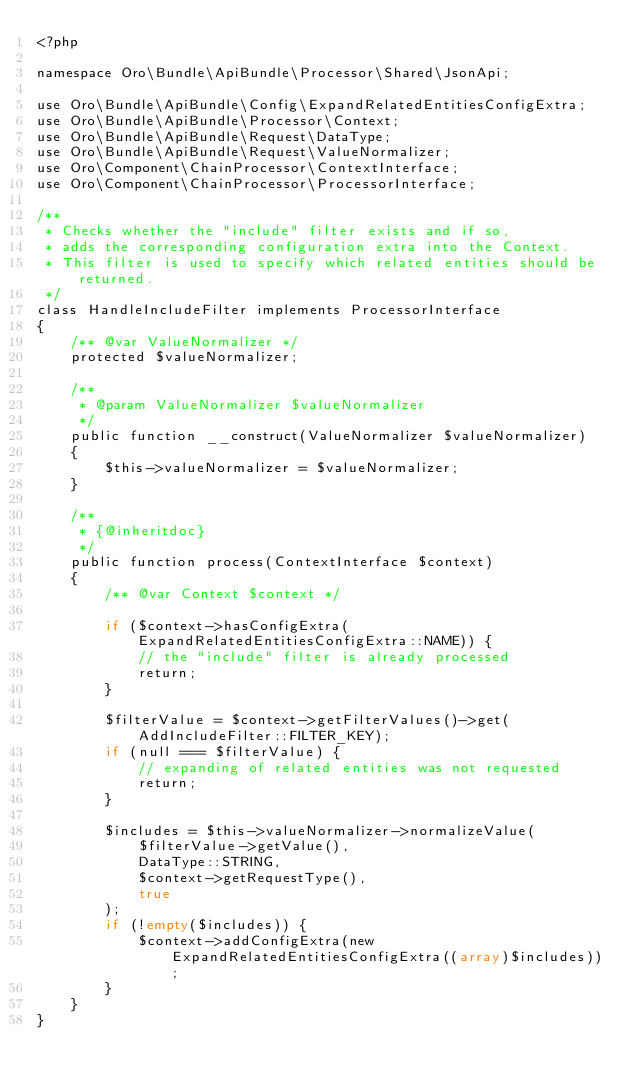Convert code to text. <code><loc_0><loc_0><loc_500><loc_500><_PHP_><?php

namespace Oro\Bundle\ApiBundle\Processor\Shared\JsonApi;

use Oro\Bundle\ApiBundle\Config\ExpandRelatedEntitiesConfigExtra;
use Oro\Bundle\ApiBundle\Processor\Context;
use Oro\Bundle\ApiBundle\Request\DataType;
use Oro\Bundle\ApiBundle\Request\ValueNormalizer;
use Oro\Component\ChainProcessor\ContextInterface;
use Oro\Component\ChainProcessor\ProcessorInterface;

/**
 * Checks whether the "include" filter exists and if so,
 * adds the corresponding configuration extra into the Context.
 * This filter is used to specify which related entities should be returned.
 */
class HandleIncludeFilter implements ProcessorInterface
{
    /** @var ValueNormalizer */
    protected $valueNormalizer;

    /**
     * @param ValueNormalizer $valueNormalizer
     */
    public function __construct(ValueNormalizer $valueNormalizer)
    {
        $this->valueNormalizer = $valueNormalizer;
    }

    /**
     * {@inheritdoc}
     */
    public function process(ContextInterface $context)
    {
        /** @var Context $context */

        if ($context->hasConfigExtra(ExpandRelatedEntitiesConfigExtra::NAME)) {
            // the "include" filter is already processed
            return;
        }

        $filterValue = $context->getFilterValues()->get(AddIncludeFilter::FILTER_KEY);
        if (null === $filterValue) {
            // expanding of related entities was not requested
            return;
        }

        $includes = $this->valueNormalizer->normalizeValue(
            $filterValue->getValue(),
            DataType::STRING,
            $context->getRequestType(),
            true
        );
        if (!empty($includes)) {
            $context->addConfigExtra(new ExpandRelatedEntitiesConfigExtra((array)$includes));
        }
    }
}
</code> 